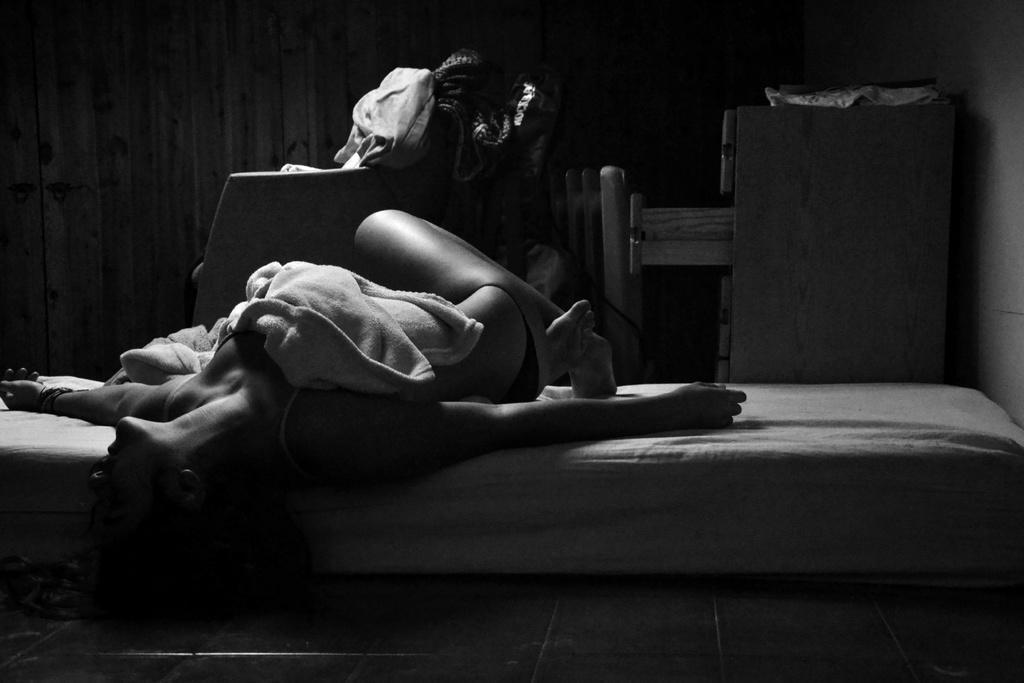How would you summarize this image in a sentence or two? There is a woman on a bed. On her body, there is a cloth. In the background, there are clothes on an object and there is a cupboard. And the background is dark in color. 